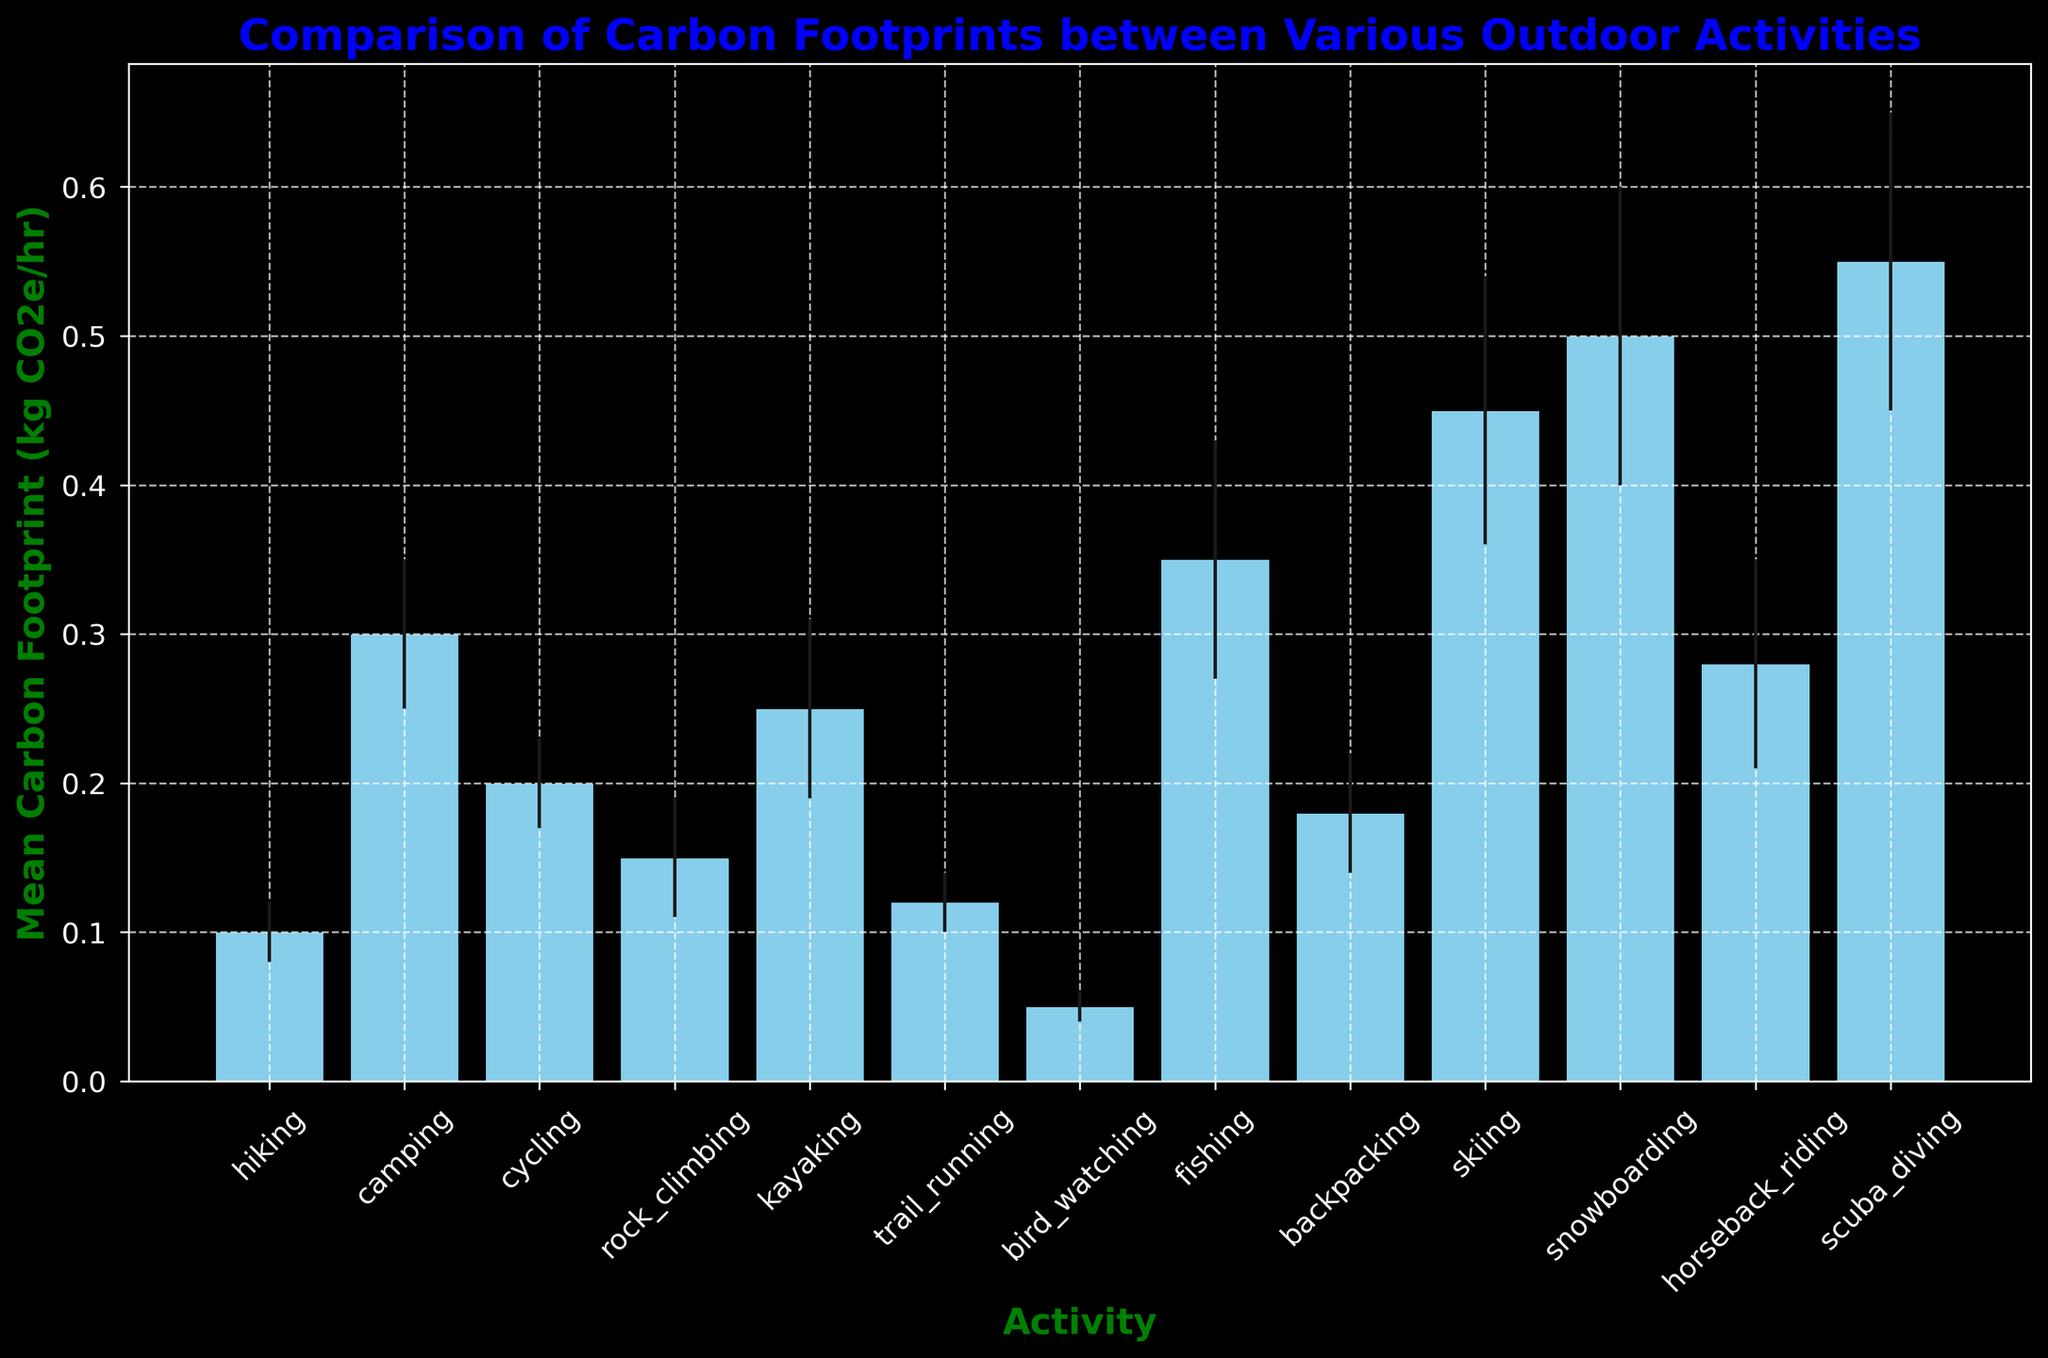What activity has the highest mean carbon footprint? To find the activity with the highest carbon footprint, compare the heights of all the bars. Scuba diving has the tallest bar.
Answer: Scuba diving Which two activities have the lowest mean carbon footprints? To find the lowest mean carbon footprints, look for the shortest bars. Hiking and bird watching have the shortest bars.
Answer: Hiking and bird watching How much greater is the mean carbon footprint of skiing compared to cycling? Skiing has a mean carbon footprint of 0.45 and cycling has 0.2. The difference is 0.45 - 0.2 = 0.25.
Answer: 0.25 What is the mean carbon footprint range for the activities shown? The highest mean value is for scuba diving at 0.55, and the lowest is for bird watching at 0.05. So, the range is 0.55 - 0.05 = 0.50.
Answer: 0.50 Which activity has a higher mean carbon footprint: kayaking or rock climbing? Kayaking has a mean carbon footprint of 0.25, while rock climbing is 0.15. Comparing the two, kayaking is higher.
Answer: Kayaking Are any two activities' mean carbon footprints within 0.03 of each other? Compare the differences: hiking and trail running differ by 0.02, cycling and rock climbing differ by 0.05, and so on. Trail running and hiking are within 0.03 of each other.
Answer: Trail running and hiking What is the mean carbon footprint for the sum of hiking, camping, and cycling? Sum the mean values: 0.1 (hiking) + 0.3 (camping) + 0.2 (cycling) = 0.6.
Answer: 0.6 Which activities have a mean carbon footprint between 0.2 and 0.3? Identify bars between 0.2 and 0.3. Cycling (0.2), kayaking (0.25), and horseback riding (0.28) fall in this range.
Answer: Cycling, kayaking, and horseback riding What is the mean carbon footprint difference between the lowest and highest mean carbon footprint activities? The lowest is bird watching at 0.05, and the highest is scuba diving at 0.55. The difference is 0.55 - 0.05 = 0.50.
Answer: 0.50 